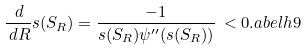Convert formula to latex. <formula><loc_0><loc_0><loc_500><loc_500>\frac { \, d } { \, d R } s ( S _ { R } ) = \frac { - 1 } { s ( S _ { R } ) \psi ^ { \prime \prime } ( s ( S _ { R } ) ) } \, < 0 . \L a b e l { h 9 }</formula> 